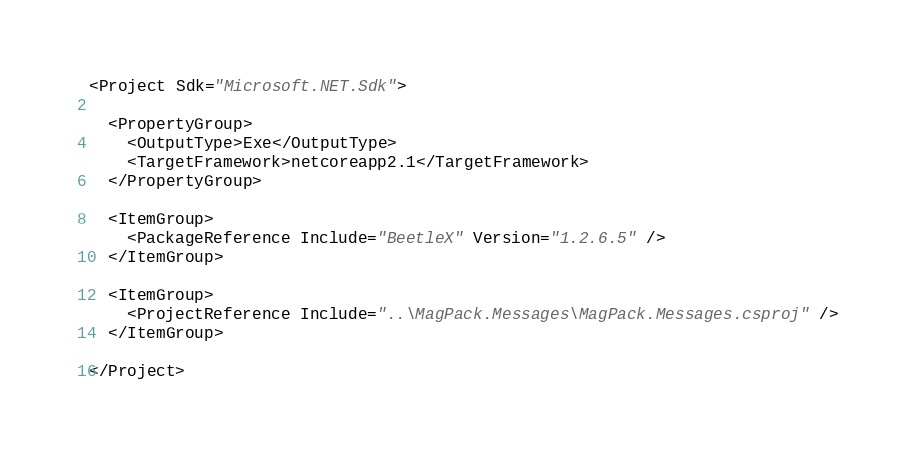<code> <loc_0><loc_0><loc_500><loc_500><_XML_><Project Sdk="Microsoft.NET.Sdk">

  <PropertyGroup>
    <OutputType>Exe</OutputType>
    <TargetFramework>netcoreapp2.1</TargetFramework>
  </PropertyGroup>

  <ItemGroup>
    <PackageReference Include="BeetleX" Version="1.2.6.5" />
  </ItemGroup>

  <ItemGroup>
    <ProjectReference Include="..\MagPack.Messages\MagPack.Messages.csproj" />
  </ItemGroup>

</Project>
</code> 